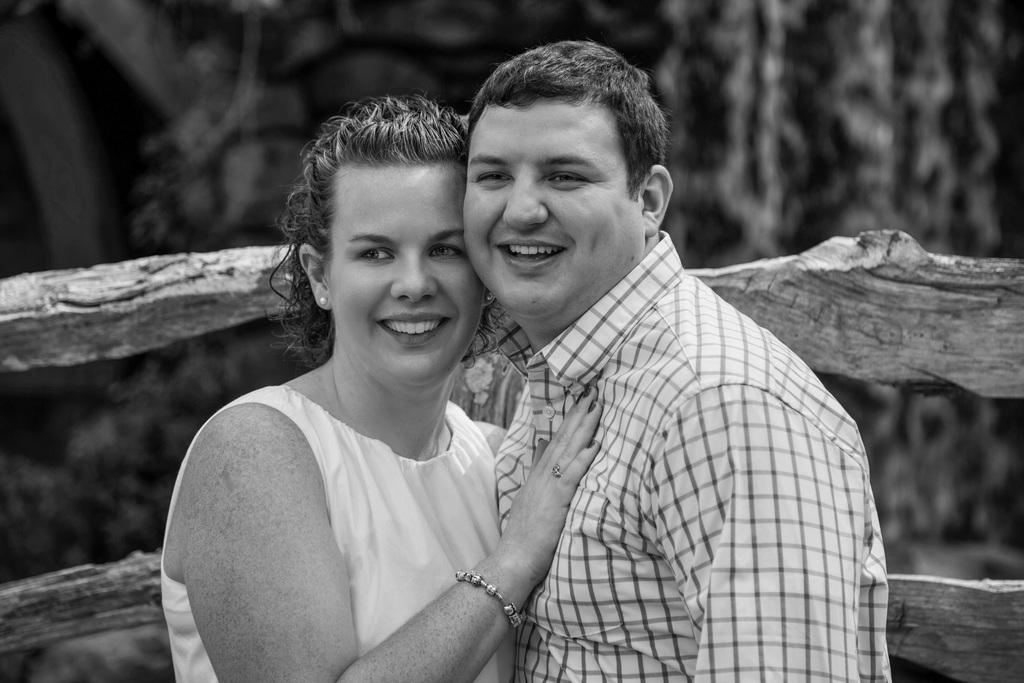How many people are in the image? There are two people in the image, a man and a woman. What are the man and woman wearing? Both the man and woman are wearing white dresses. What are the man and woman doing in the image? The man and woman are standing and hugging each other. What can be seen in the background of the image? There is fencing in the background of the image. What type of stem can be seen growing from the man's teeth in the image? There is no stem or any plant-related object visible in the man's teeth in the image. 